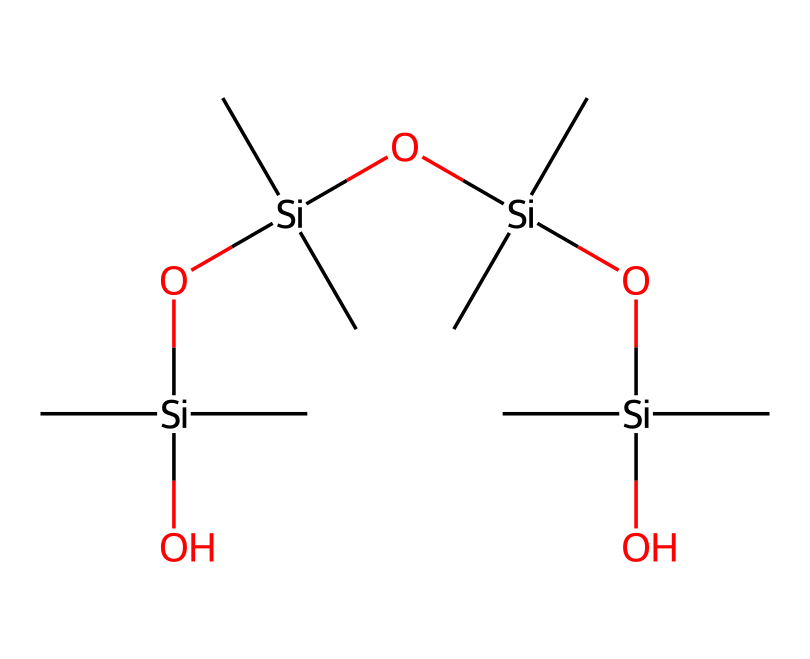What is the main element in the silicone rubber structure? The SMILES representation shows silicon atoms (Si) as the primary element connecting the different parts of the polymer chain.
Answer: silicon How many silicon atoms are present in the structure? By analyzing the SMILES code, we can count four silicon atoms directly mentioned, including the ones in the branching and backbone.
Answer: four What type of bonds primarily connect the silicon atoms? The structure indicates that silicon atoms are bonded through silicon-oxygen (Si-O) connections, which are typical in siloxane linkages in silicone polymers.
Answer: Si-O What functional groups are present in this silicone rubber? The presence of the hydroxyl (–OH) groups indicated by the oxygen linked to silicon suggests that there are functional groups that enhance the flexibility and usability of the rubber.
Answer: hydroxyl What is the repeating unit of this polymer structure? The repeating unit can be identified as the -Si- group connected with -O- and -C- groups, which makes a basic silicone backbone that repeats throughout the structure.
Answer: -Si-O- What characteristic of silicone rubber allows it to be used in prosthetics? The flexibility and durability of silicone, as indicated by its polymeric structure that can withstand deformation and retain shape, make it ideal for prosthetic applications.
Answer: flexibility 